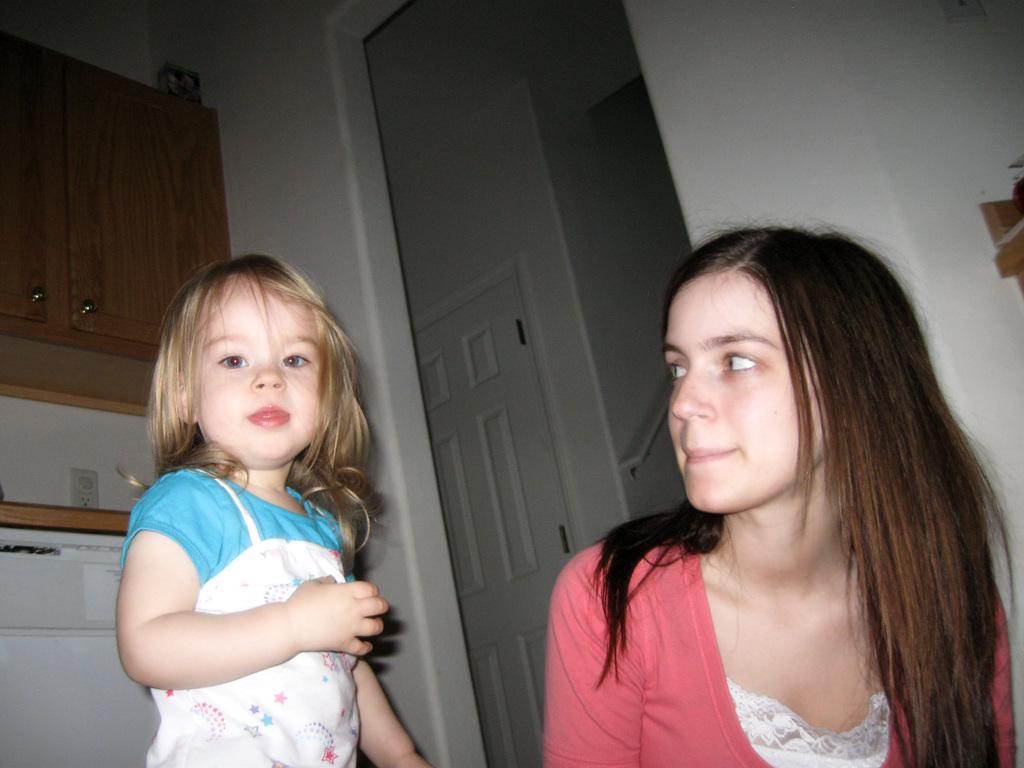Who is the small girl standing beside in the image? The small girl is standing beside a lady in the image. What can be seen in the background of the image? There are wooden cupboards and a door in the background of the image. How does the small girl blow air through the door in the image? The small girl does not blow air through the door in the image; there is no indication of her doing so. 